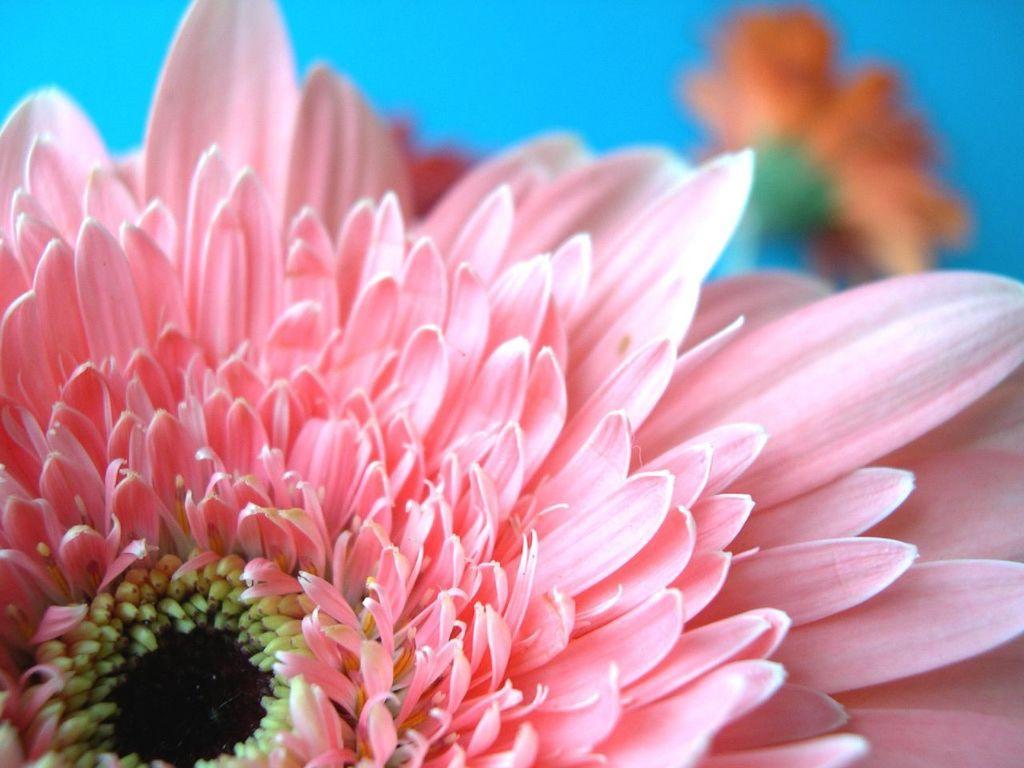How would you summarize this image in a sentence or two? In this image I can see the flower which is in yellow, black and pink color. In the back I can see few more flowers and I can see the blue color background. 